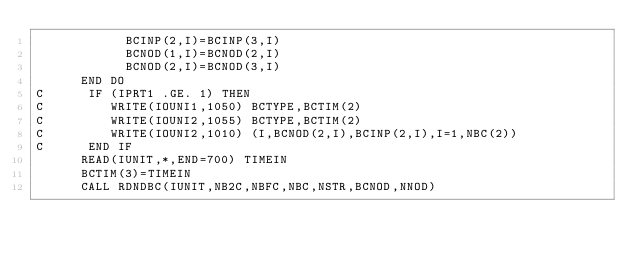<code> <loc_0><loc_0><loc_500><loc_500><_FORTRAN_>            BCINP(2,I)=BCINP(3,I)
            BCNOD(1,I)=BCNOD(2,I)
            BCNOD(2,I)=BCNOD(3,I)
      END DO
C      IF (IPRT1 .GE. 1) THEN
C         WRITE(IOUNI1,1050) BCTYPE,BCTIM(2)
C         WRITE(IOUNI2,1055) BCTYPE,BCTIM(2)
C         WRITE(IOUNI2,1010) (I,BCNOD(2,I),BCINP(2,I),I=1,NBC(2))
C      END IF
      READ(IUNIT,*,END=700) TIMEIN
      BCTIM(3)=TIMEIN
      CALL RDNDBC(IUNIT,NB2C,NBFC,NBC,NSTR,BCNOD,NNOD)</code> 